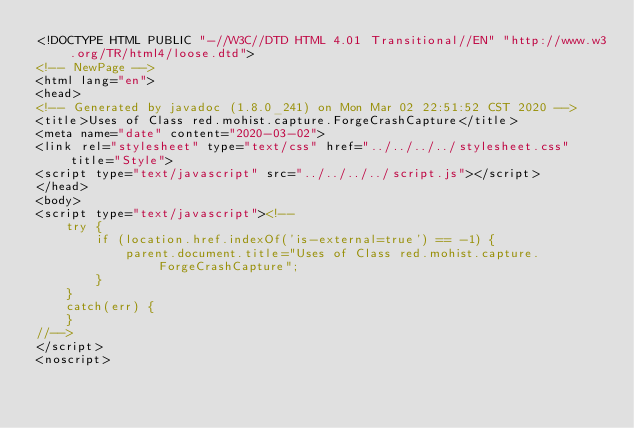Convert code to text. <code><loc_0><loc_0><loc_500><loc_500><_HTML_><!DOCTYPE HTML PUBLIC "-//W3C//DTD HTML 4.01 Transitional//EN" "http://www.w3.org/TR/html4/loose.dtd">
<!-- NewPage -->
<html lang="en">
<head>
<!-- Generated by javadoc (1.8.0_241) on Mon Mar 02 22:51:52 CST 2020 -->
<title>Uses of Class red.mohist.capture.ForgeCrashCapture</title>
<meta name="date" content="2020-03-02">
<link rel="stylesheet" type="text/css" href="../../../../stylesheet.css" title="Style">
<script type="text/javascript" src="../../../../script.js"></script>
</head>
<body>
<script type="text/javascript"><!--
    try {
        if (location.href.indexOf('is-external=true') == -1) {
            parent.document.title="Uses of Class red.mohist.capture.ForgeCrashCapture";
        }
    }
    catch(err) {
    }
//-->
</script>
<noscript></code> 